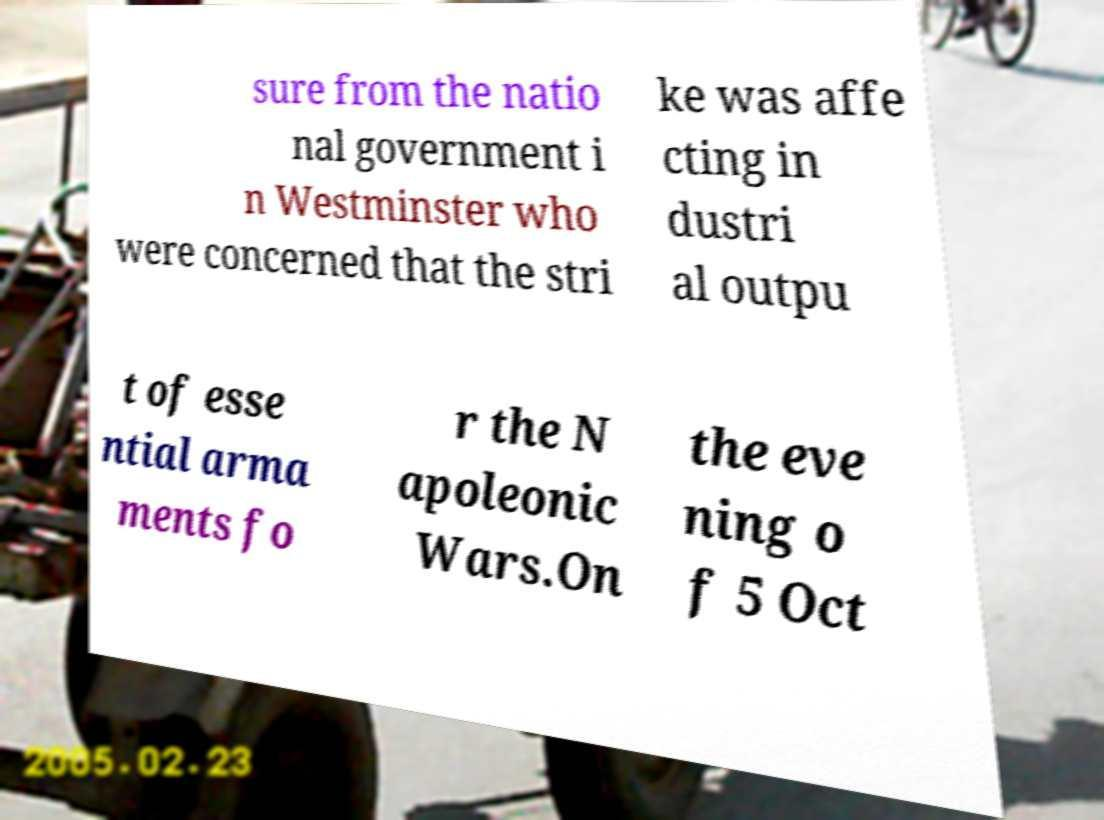Please identify and transcribe the text found in this image. sure from the natio nal government i n Westminster who were concerned that the stri ke was affe cting in dustri al outpu t of esse ntial arma ments fo r the N apoleonic Wars.On the eve ning o f 5 Oct 